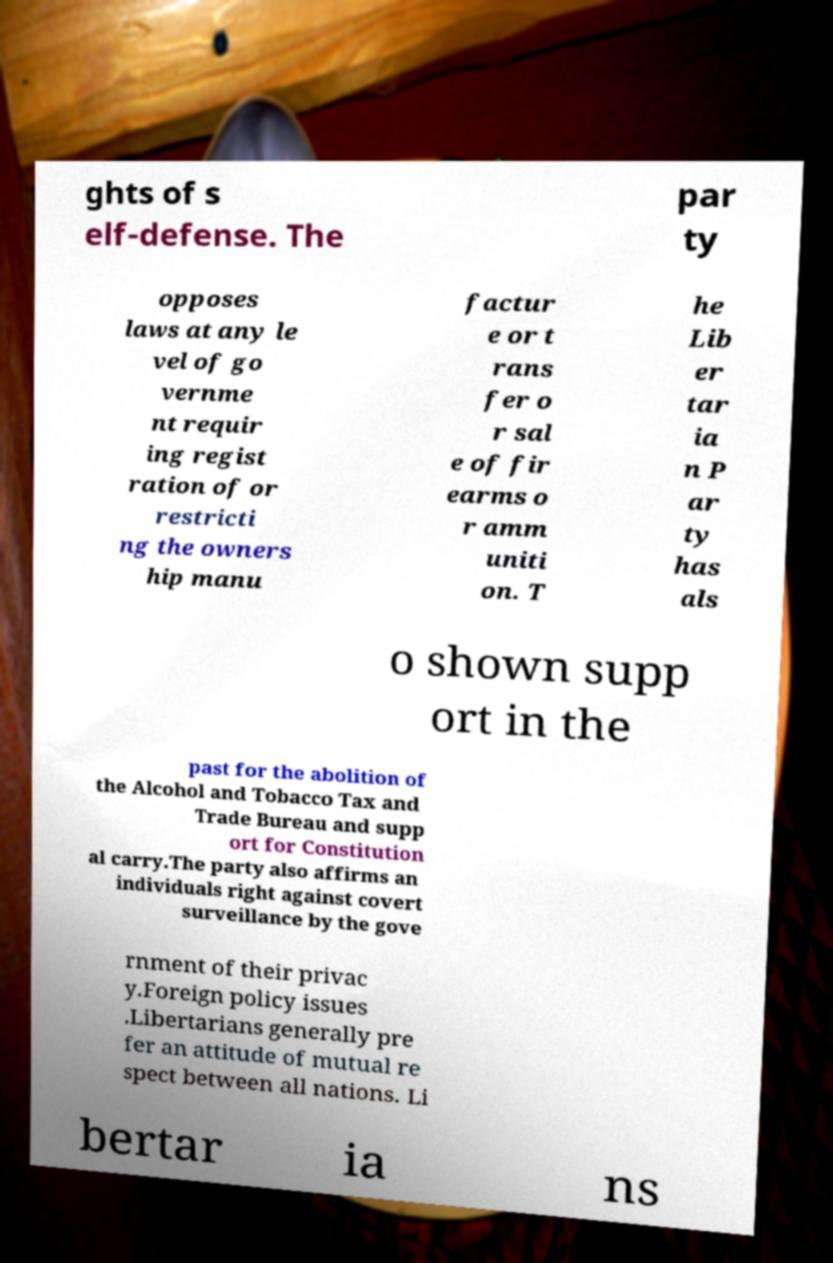Can you read and provide the text displayed in the image?This photo seems to have some interesting text. Can you extract and type it out for me? ghts of s elf-defense. The par ty opposes laws at any le vel of go vernme nt requir ing regist ration of or restricti ng the owners hip manu factur e or t rans fer o r sal e of fir earms o r amm uniti on. T he Lib er tar ia n P ar ty has als o shown supp ort in the past for the abolition of the Alcohol and Tobacco Tax and Trade Bureau and supp ort for Constitution al carry.The party also affirms an individuals right against covert surveillance by the gove rnment of their privac y.Foreign policy issues .Libertarians generally pre fer an attitude of mutual re spect between all nations. Li bertar ia ns 